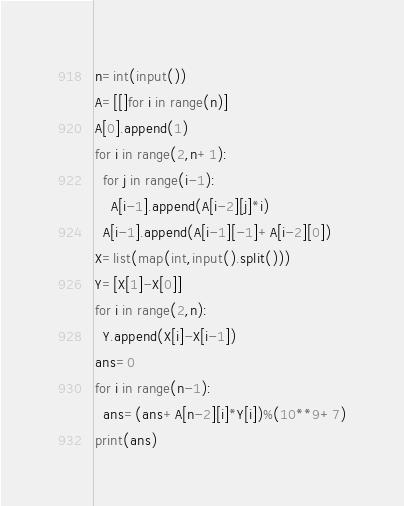<code> <loc_0><loc_0><loc_500><loc_500><_Python_>n=int(input())
A=[[]for i in range(n)]
A[0].append(1)
for i in range(2,n+1):
  for j in range(i-1):
    A[i-1].append(A[i-2][j]*i)
  A[i-1].append(A[i-1][-1]+A[i-2][0])
X=list(map(int,input().split()))
Y=[X[1]-X[0]]
for i in range(2,n):
  Y.append(X[i]-X[i-1])
ans=0
for i in range(n-1):
  ans=(ans+A[n-2][i]*Y[i])%(10**9+7)
print(ans)
</code> 